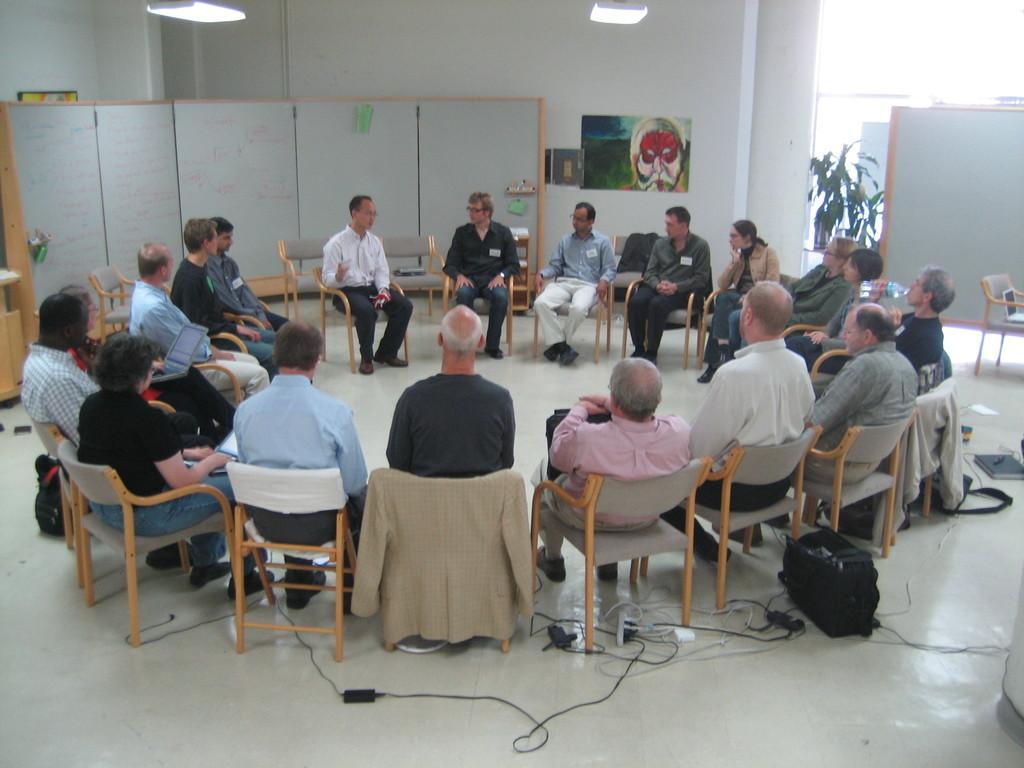Could you give a brief overview of what you see in this image? In the picture we can find a group of people sitting on a chairs. In the background we can find a wall, a painting, plant and some lights in the ceiling. 